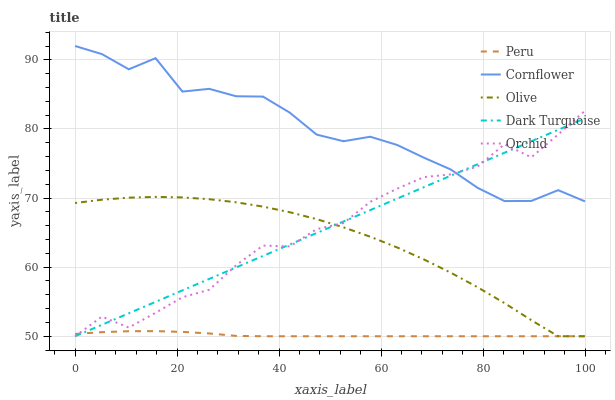Does Peru have the minimum area under the curve?
Answer yes or no. Yes. Does Cornflower have the maximum area under the curve?
Answer yes or no. Yes. Does Orchid have the minimum area under the curve?
Answer yes or no. No. Does Orchid have the maximum area under the curve?
Answer yes or no. No. Is Dark Turquoise the smoothest?
Answer yes or no. Yes. Is Orchid the roughest?
Answer yes or no. Yes. Is Cornflower the smoothest?
Answer yes or no. No. Is Cornflower the roughest?
Answer yes or no. No. Does Olive have the lowest value?
Answer yes or no. Yes. Does Cornflower have the lowest value?
Answer yes or no. No. Does Cornflower have the highest value?
Answer yes or no. Yes. Does Orchid have the highest value?
Answer yes or no. No. Is Olive less than Cornflower?
Answer yes or no. Yes. Is Cornflower greater than Peru?
Answer yes or no. Yes. Does Orchid intersect Dark Turquoise?
Answer yes or no. Yes. Is Orchid less than Dark Turquoise?
Answer yes or no. No. Is Orchid greater than Dark Turquoise?
Answer yes or no. No. Does Olive intersect Cornflower?
Answer yes or no. No. 